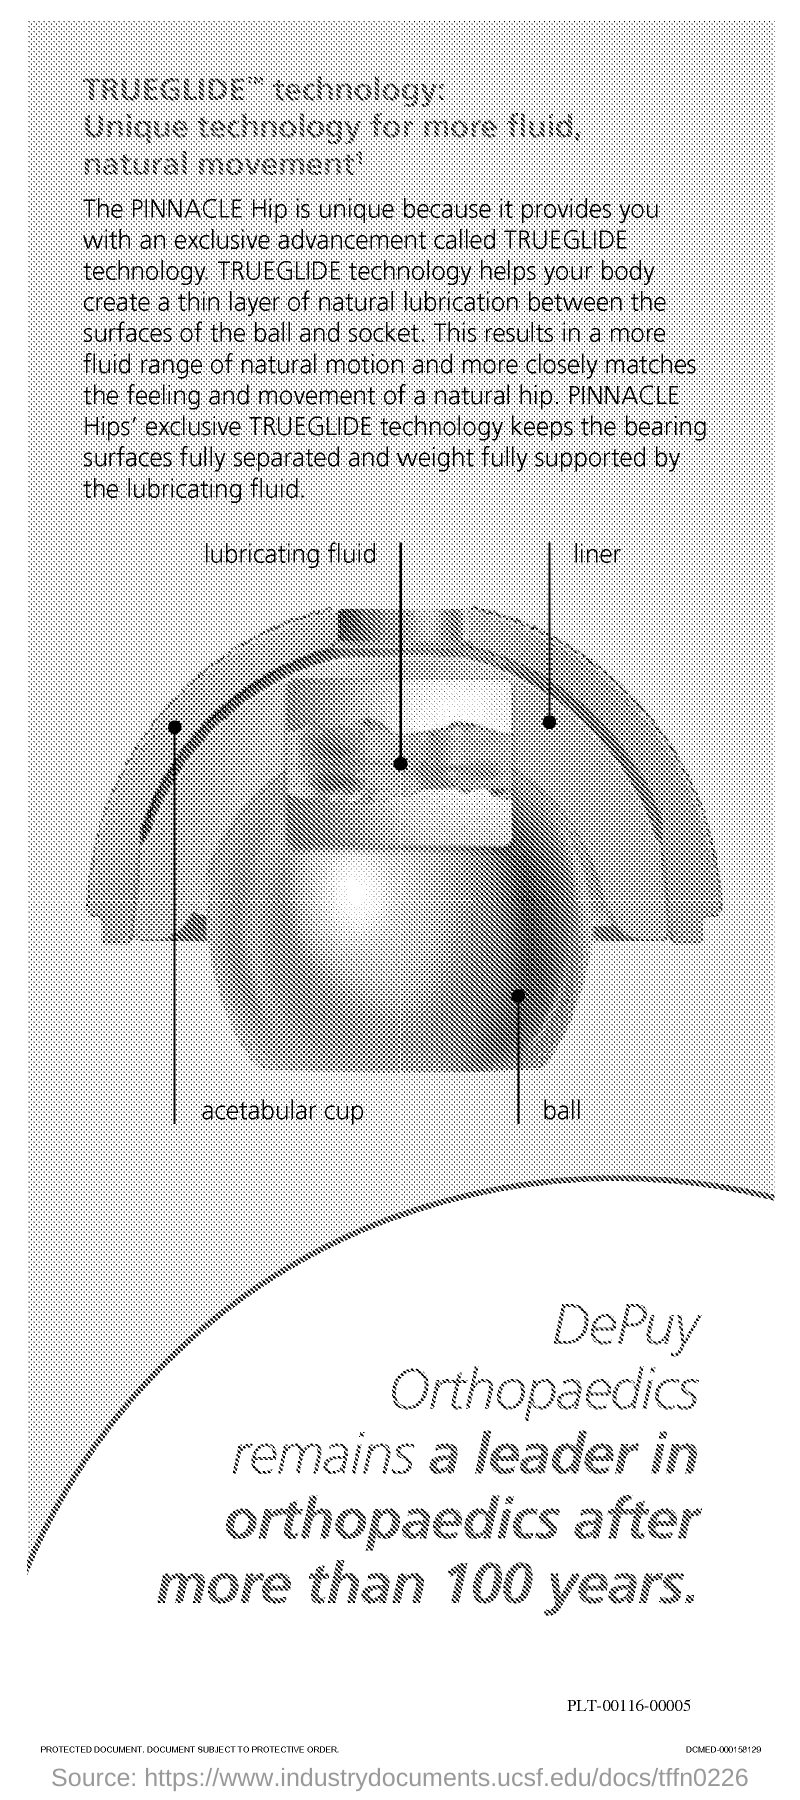What is the name of the technology specified in the title of this page?
Your response must be concise. TRUEGLIDE. Why is PINNACLE Hip unique?
Offer a terse response. Because it provides you with an exclusive advancement called TRUeGLIDE technology. How does TRUEGLIDE technology help?
Offer a terse response. Create a thin layer of natural lubrication between the surfaces of the ball and socket. Which technology makes PINNACLE hip unique?
Make the answer very short. TRUEGLIDE technology. What is the exclusive technology of PINNACLE hips?
Give a very brief answer. TRUEGLIDE. 